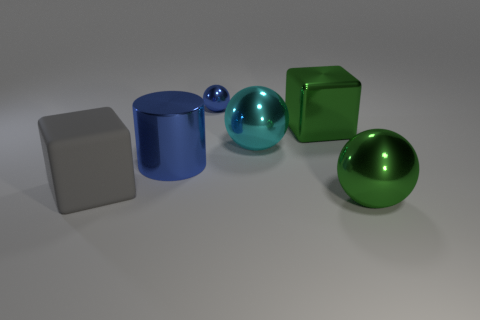Is there any other thing that has the same shape as the large blue shiny thing?
Your response must be concise. No. What shape is the large blue object that is in front of the large cyan metal ball?
Offer a terse response. Cylinder. Do the blue cylinder and the big green object that is in front of the large gray rubber block have the same material?
Keep it short and to the point. Yes. What number of other objects are the same shape as the cyan metallic object?
Your answer should be compact. 2. Does the cylinder have the same color as the large block behind the big matte cube?
Offer a very short reply. No. Is there anything else that is the same material as the small blue thing?
Your answer should be very brief. Yes. There is a big green shiny object that is left of the thing in front of the gray matte cube; what shape is it?
Your response must be concise. Cube. What size is the shiny thing that is the same color as the cylinder?
Provide a short and direct response. Small. There is a blue thing that is behind the big cyan metal ball; does it have the same shape as the cyan thing?
Your answer should be compact. Yes. Are there more green objects that are on the left side of the cyan ball than large shiny cubes on the left side of the tiny sphere?
Offer a terse response. No. 